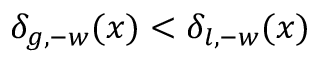Convert formula to latex. <formula><loc_0><loc_0><loc_500><loc_500>\delta _ { g , - w } ( x ) < \delta _ { l , - w } ( x )</formula> 